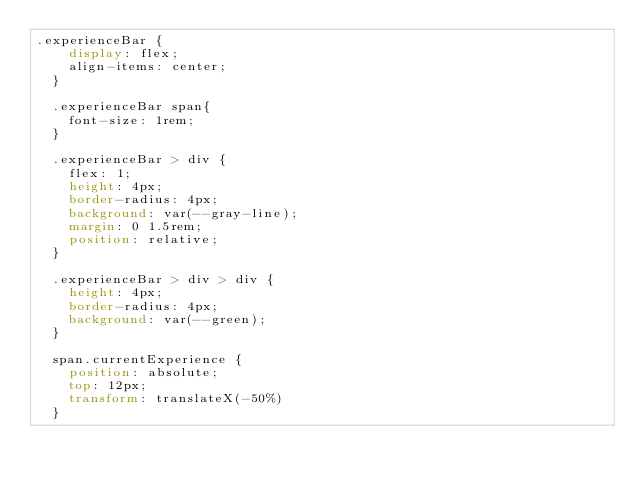Convert code to text. <code><loc_0><loc_0><loc_500><loc_500><_CSS_>.experienceBar {
    display: flex;
    align-items: center;
  }
  
  .experienceBar span{
    font-size: 1rem;
  }
  
  .experienceBar > div {
    flex: 1;
    height: 4px;
    border-radius: 4px;
    background: var(--gray-line);
    margin: 0 1.5rem;
    position: relative;
  }
  
  .experienceBar > div > div {
    height: 4px;
    border-radius: 4px;
    background: var(--green);
  }
  
  span.currentExperience {
    position: absolute;
    top: 12px;
    transform: translateX(-50%)
  }</code> 